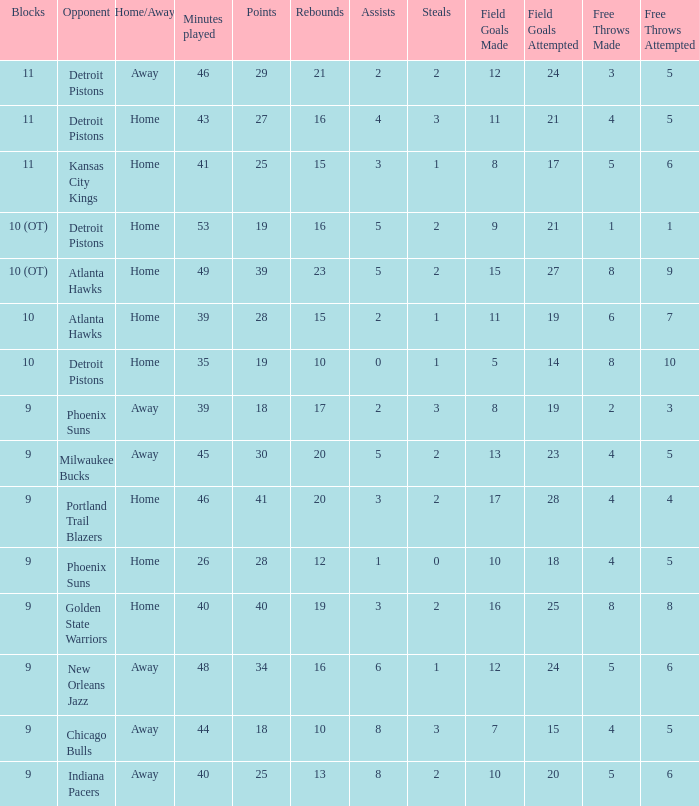How many points were there when there were less than 16 rebounds and 5 assists? 0.0. 